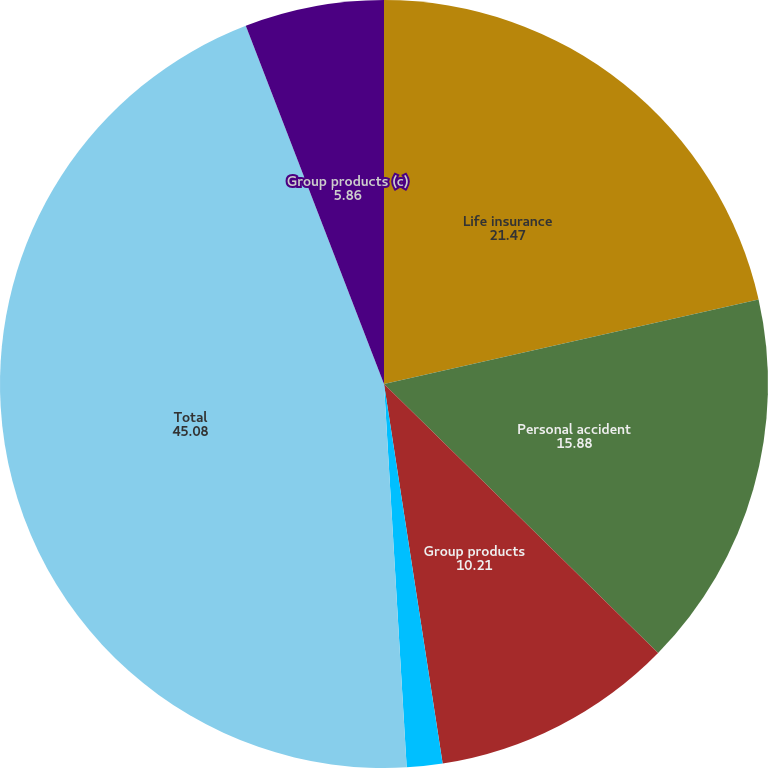<chart> <loc_0><loc_0><loc_500><loc_500><pie_chart><fcel>Life insurance<fcel>Personal accident<fcel>Group products<fcel>Individual fixed annuities<fcel>Total<fcel>Group products (c)<nl><fcel>21.47%<fcel>15.88%<fcel>10.21%<fcel>1.5%<fcel>45.08%<fcel>5.86%<nl></chart> 